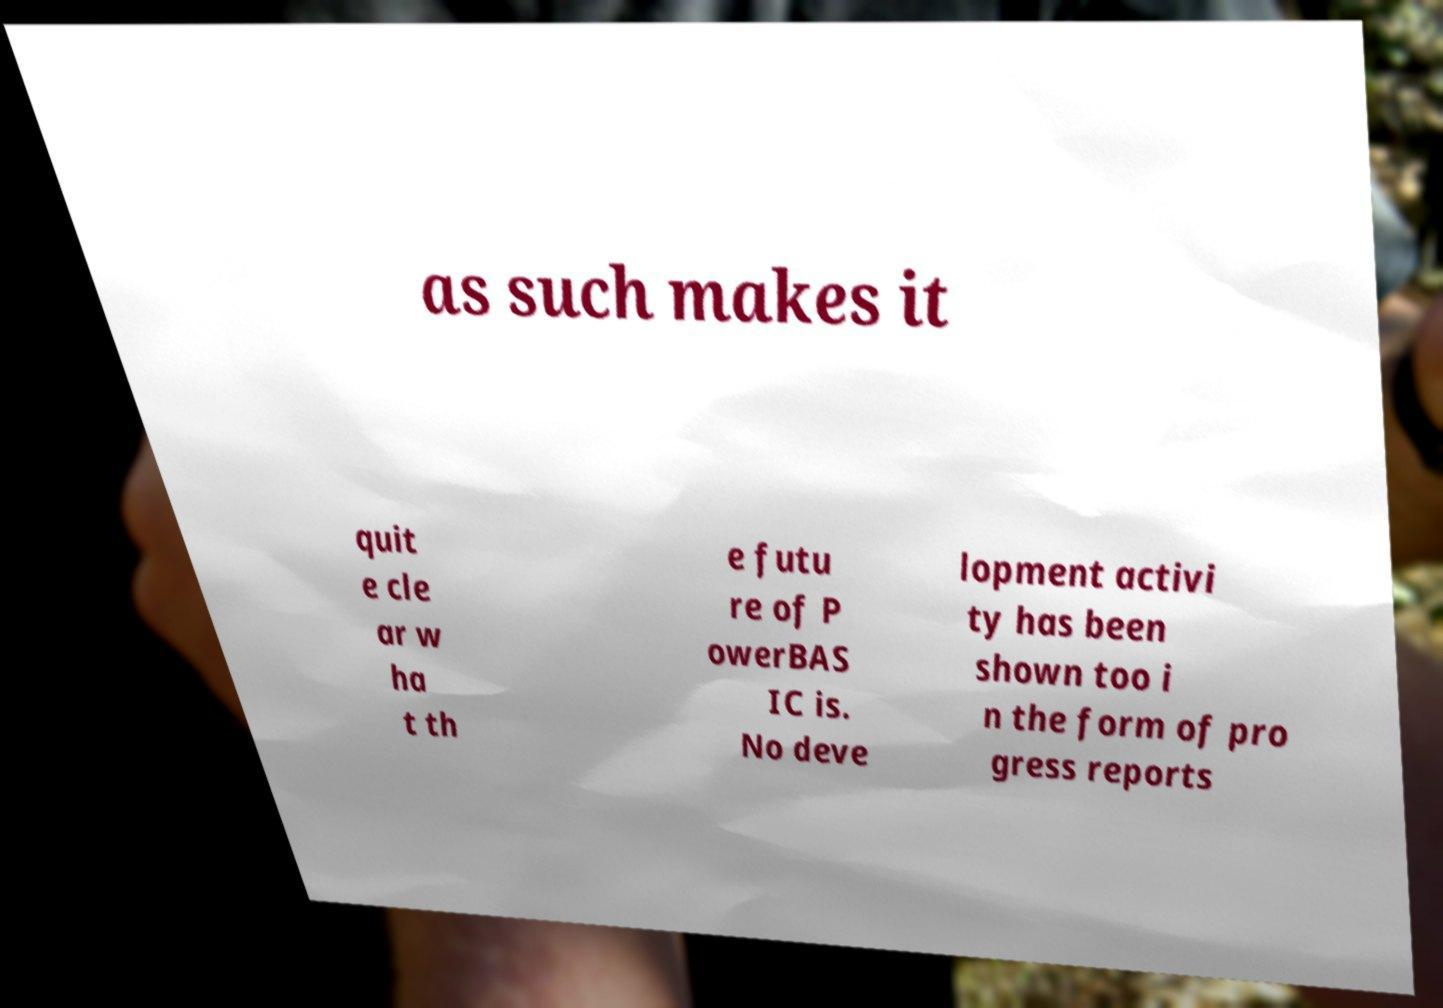For documentation purposes, I need the text within this image transcribed. Could you provide that? as such makes it quit e cle ar w ha t th e futu re of P owerBAS IC is. No deve lopment activi ty has been shown too i n the form of pro gress reports 